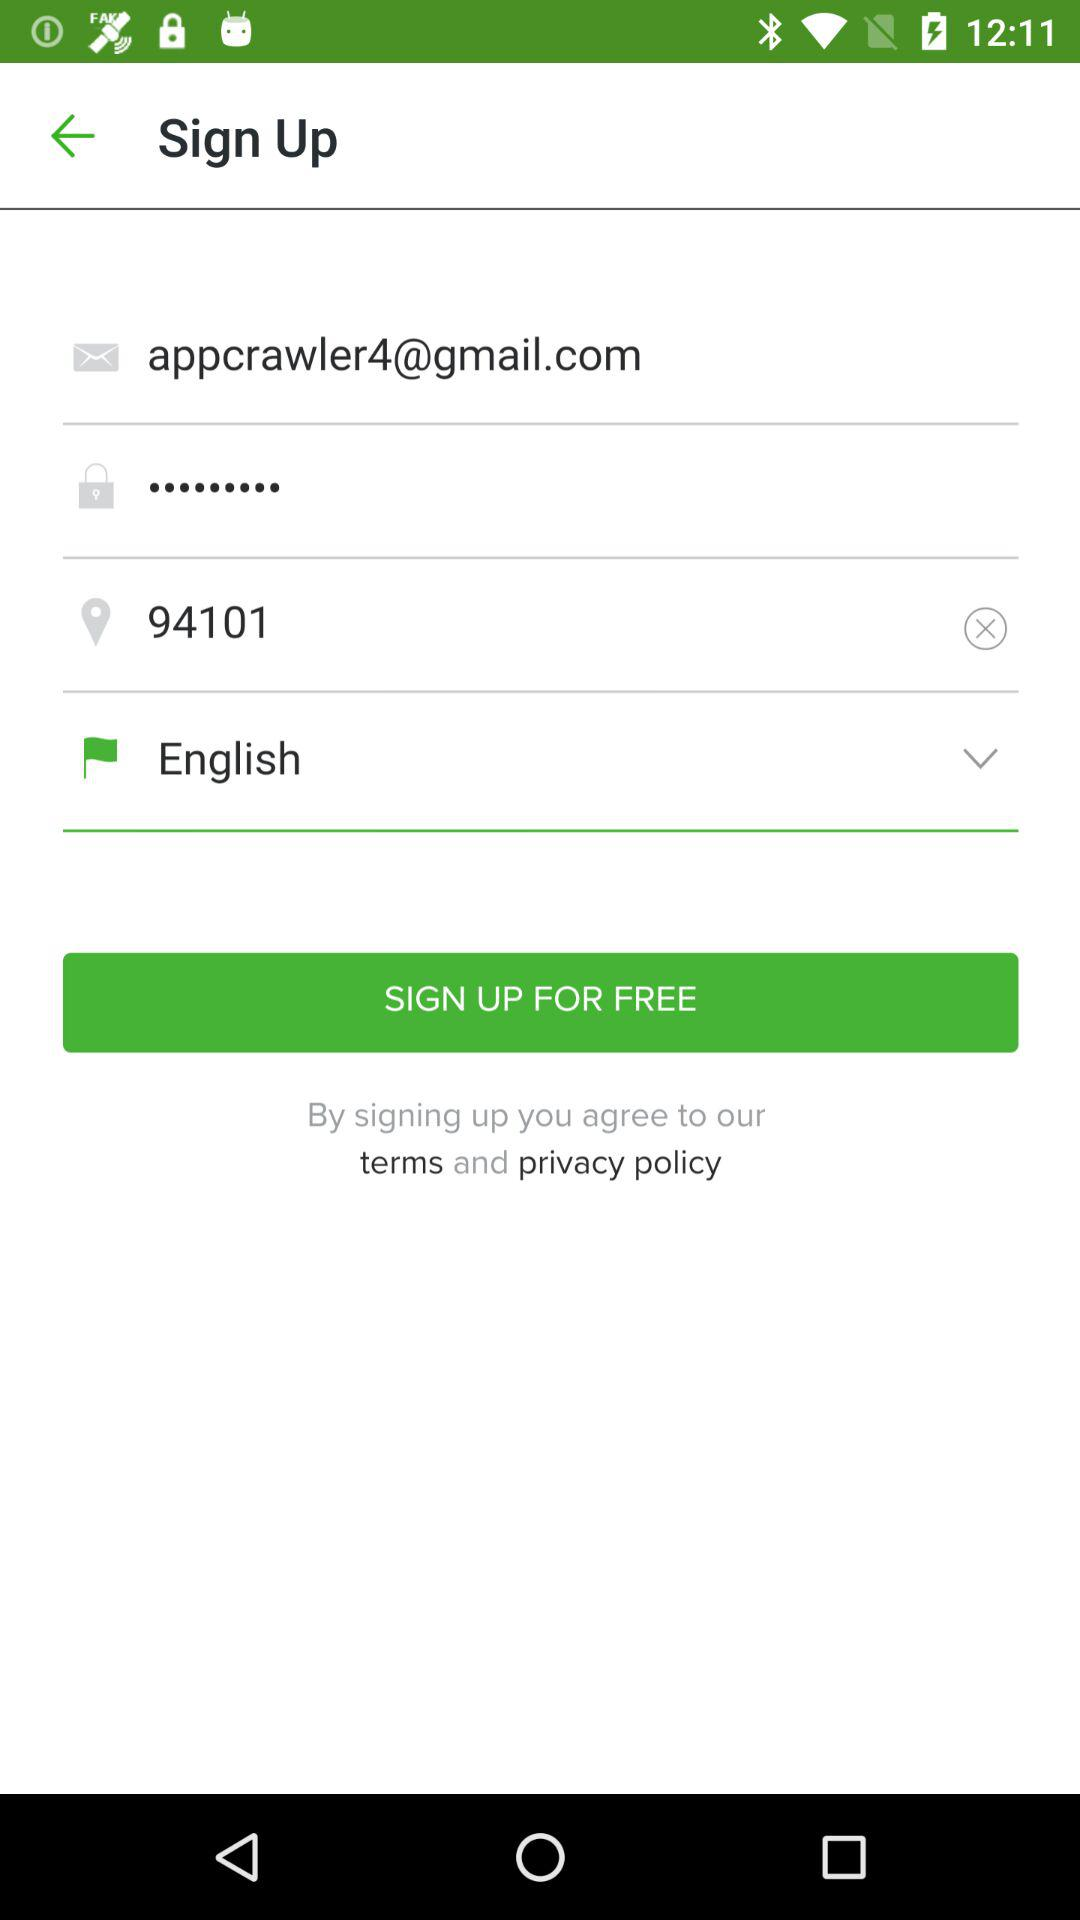Which is the selected language? The selected language is English. 